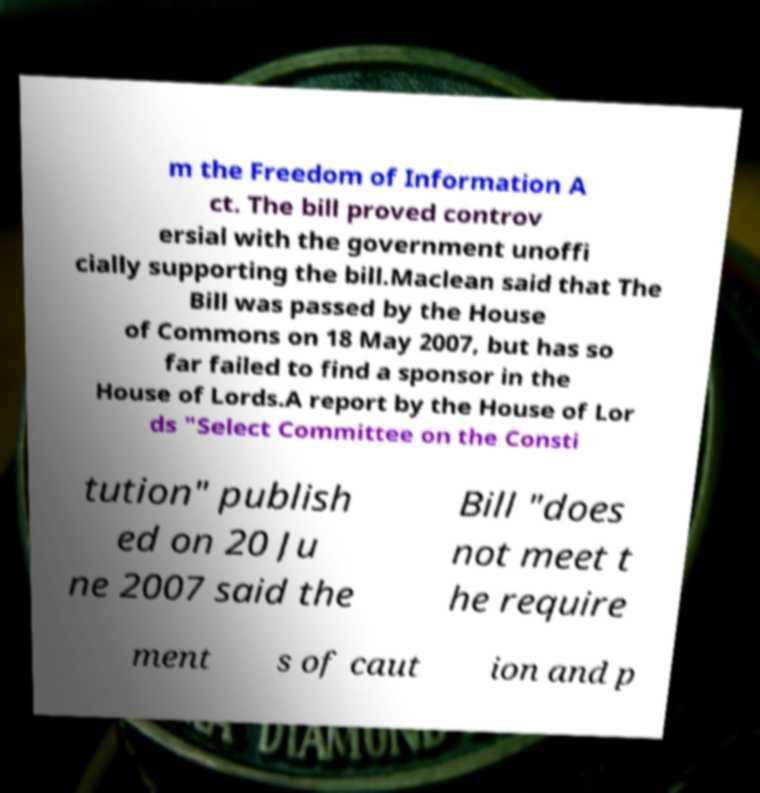For documentation purposes, I need the text within this image transcribed. Could you provide that? m the Freedom of Information A ct. The bill proved controv ersial with the government unoffi cially supporting the bill.Maclean said that The Bill was passed by the House of Commons on 18 May 2007, but has so far failed to find a sponsor in the House of Lords.A report by the House of Lor ds "Select Committee on the Consti tution" publish ed on 20 Ju ne 2007 said the Bill "does not meet t he require ment s of caut ion and p 